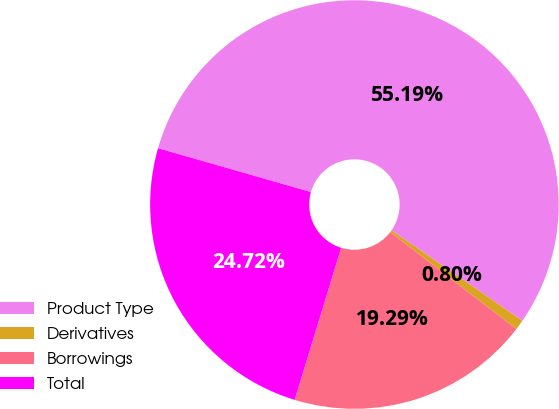<chart> <loc_0><loc_0><loc_500><loc_500><pie_chart><fcel>Product Type<fcel>Derivatives<fcel>Borrowings<fcel>Total<nl><fcel>55.19%<fcel>0.8%<fcel>19.29%<fcel>24.72%<nl></chart> 